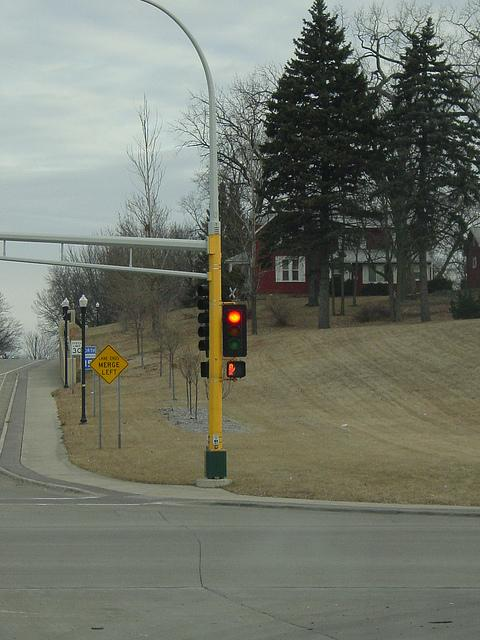Where is the house located?

Choices:
A) beach
B) lake
C) hill
D) valley hill 